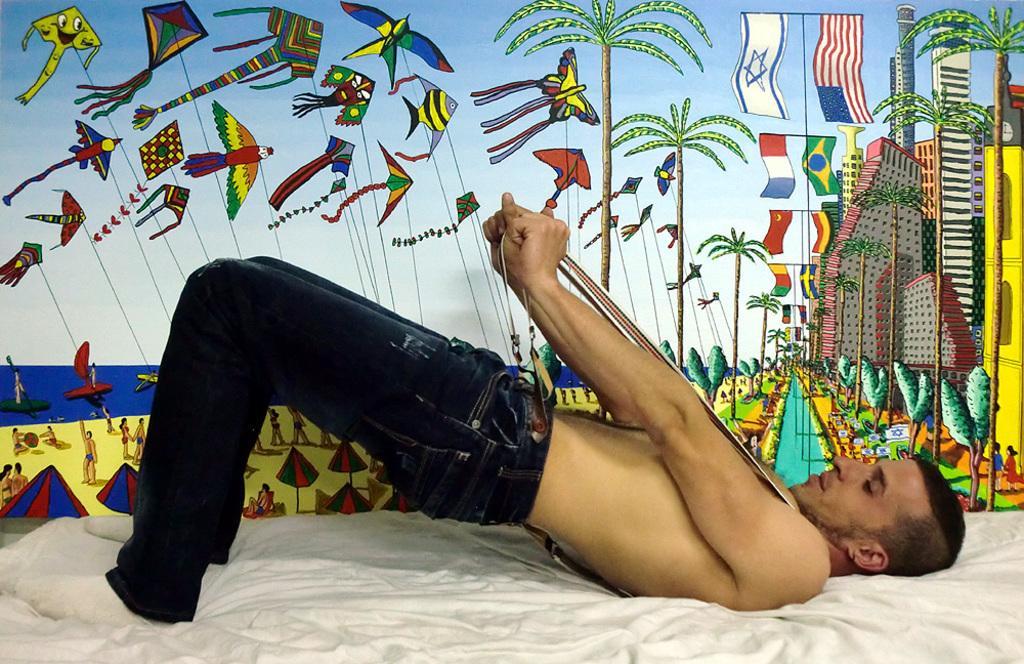Describe this image in one or two sentences. There is a person on a bed is holding a belt. In the back there is a wall with painting of kites, birds, flags, building, trees, people, tents and many other things. 